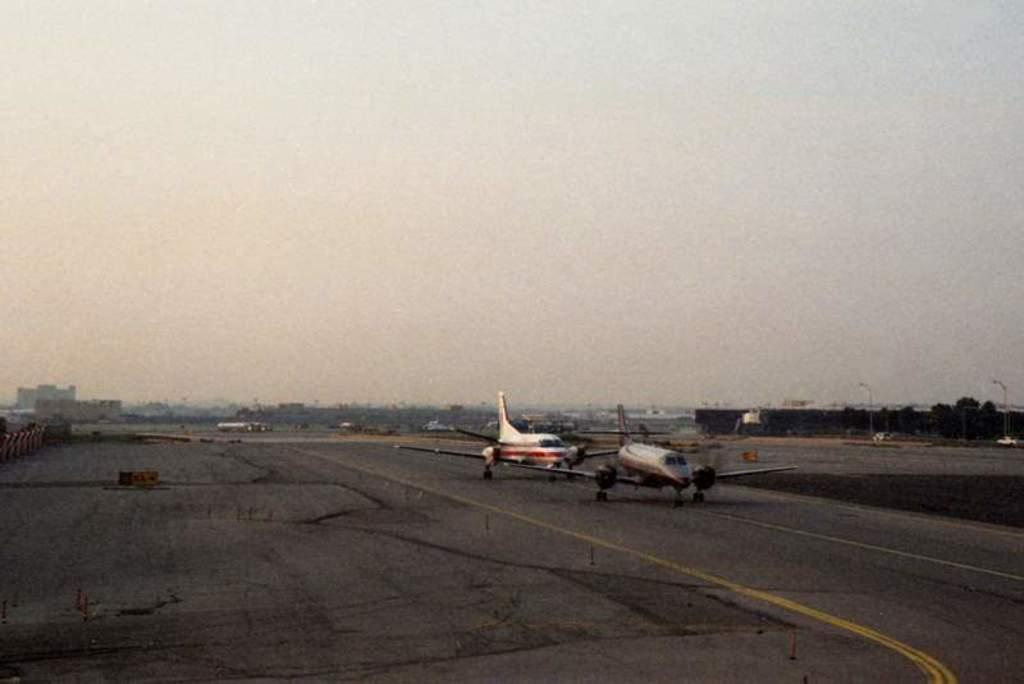What can be seen on the runway in the image? There are aeroplanes on the runway in the image. What else is visible in the image besides the runway? There are buildings, trees, and a car parked in the image. What is the condition of the sky in the image? The sky is cloudy in the image. What type of balloon is being used to express anger in the image? There is no balloon or expression of anger present in the image. What part of the human body can be seen in the image? There is no human body visible in the image. 